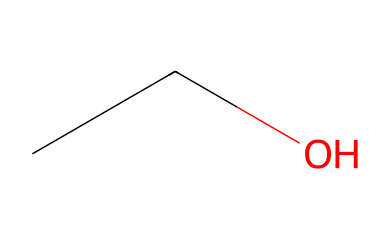What is the chemical name represented by this SMILES? The SMILES "CCO" corresponds to the structural formula of ethanol, which has the common name ethyl alcohol. The letters "CC" indicate two carbon atoms connected, and "O" indicates the presence of one oxygen in the structure, typical for ethanol.
Answer: ethanol How many carbon atoms are in the chemical? In the SMILES representation "CCO," there are two "C" letters which represent two carbon atoms. This indicates that ethanol has a total of two carbon atoms in its structure.
Answer: 2 What type of functional group is present in this chemical? The "O" in the SMILES "CCO" indicates the presence of a hydroxyl group (-OH), which is characteristic of alcohols. Therefore, this chemical has an alcohol functional group.
Answer: alcohol Is this chemical polar or nonpolar? Since ethanol has a hydroxyl group (-OH) that is polar, the overall molecule is polar as well. The presence of the oxygen atom bonded to hydrogen creates a dipole moment, indicating polarity.
Answer: polar What is the molecular formula for this chemical? The two carbon atoms (C) and six hydrogen atoms (H) combined with one oxygen atom (O) give the molecular formula C2H6O. To derive this, the number of each type of atom is counted based on the structure represented by the SMILES.
Answer: C2H6O At room temperature, is this chemical typically a solid, liquid, or gas? Ethanol is a liquid at room temperature as it has a boiling point around 78°C, which is much lower than room temperature. This indicates its state at standard conditions.
Answer: liquid 